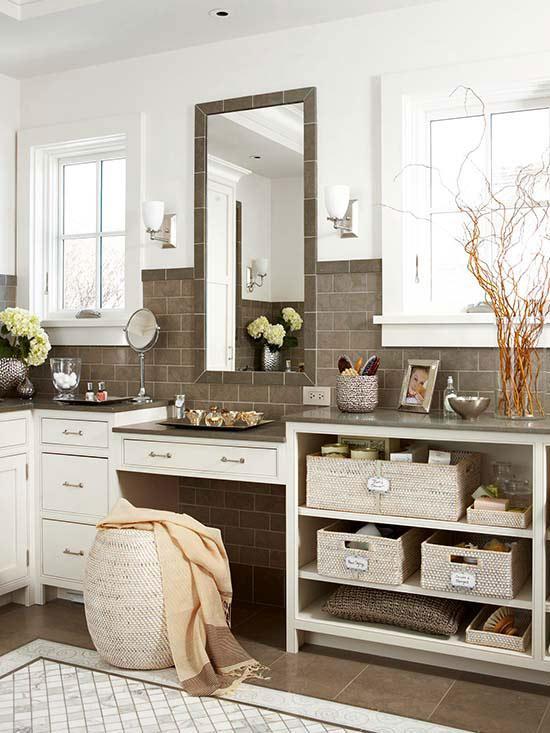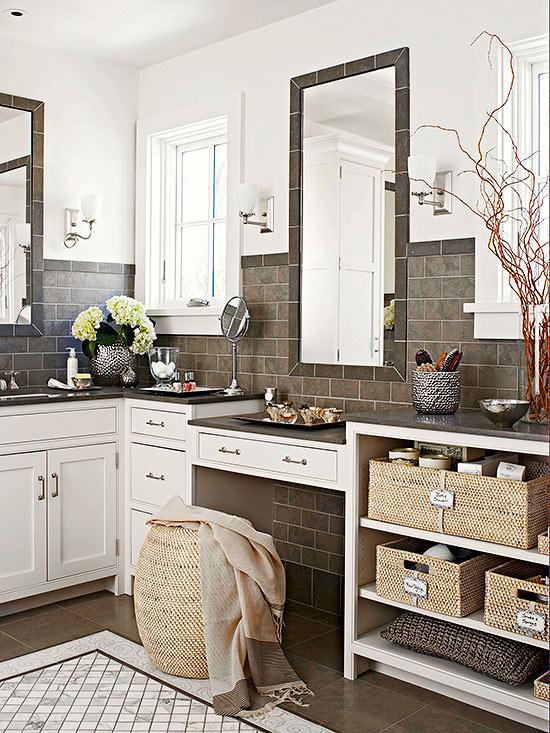The first image is the image on the left, the second image is the image on the right. Considering the images on both sides, is "In one image, a white pedestal sink stands against a wall." valid? Answer yes or no. No. 